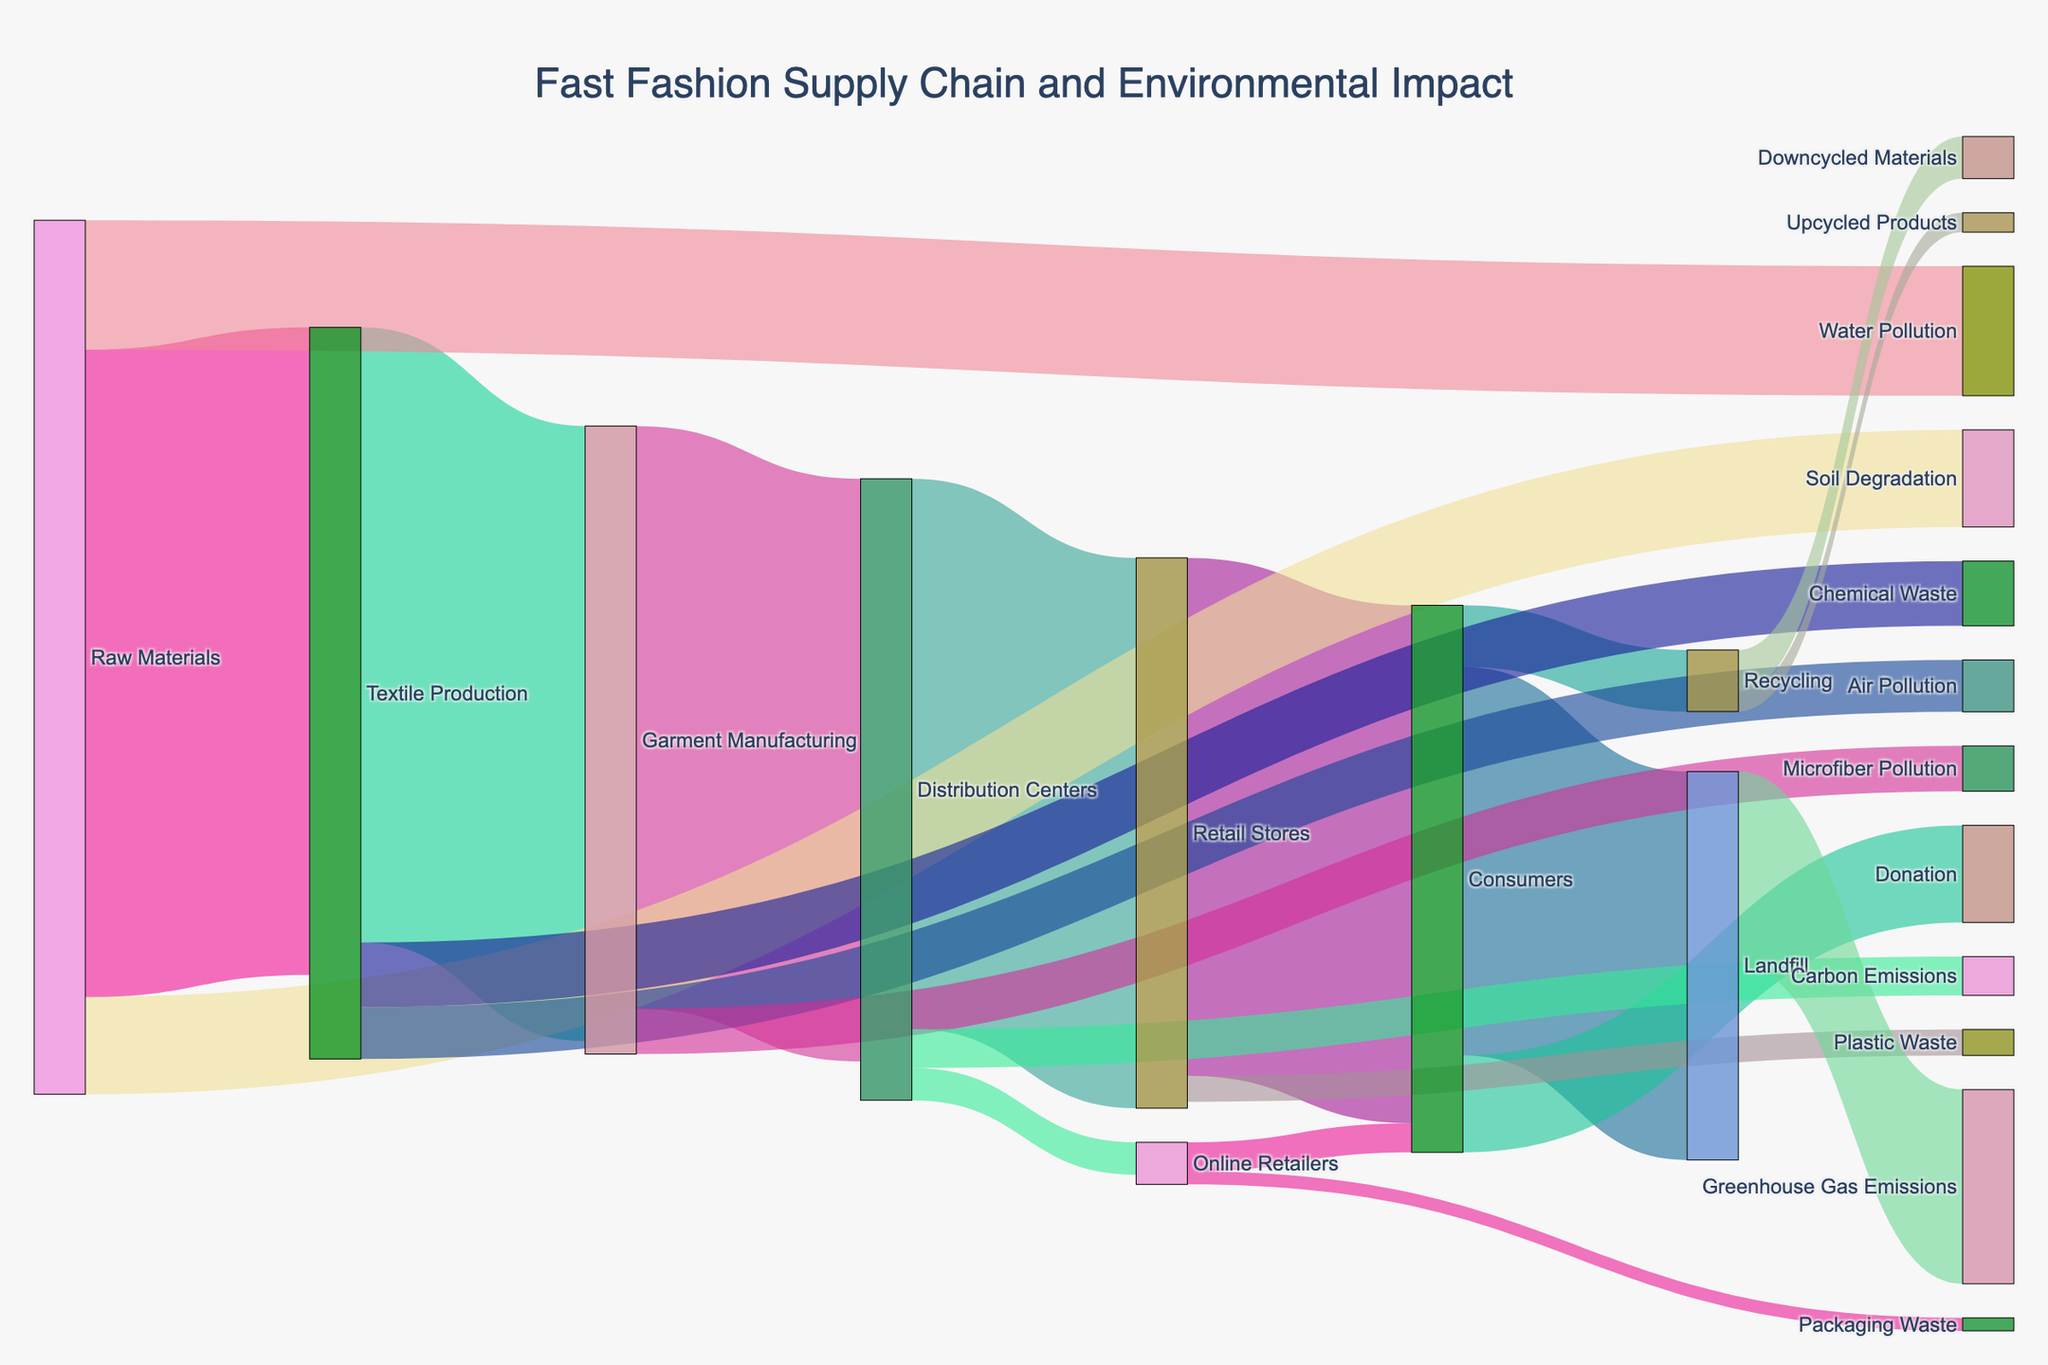What is the title of the Sankey diagram? The title is usually displayed at the top center of the diagram. Here, it reads "Fast Fashion Supply Chain and Environmental Impact".
Answer: Fast Fashion Supply Chain and Environmental Impact What process has the highest value flowing to Distribution Centers? Observing the flow into Distribution Centers, the highest value comes from Garment Manufacturing, with a value of 900.
Answer: Garment Manufacturing What's the sum of the values flowing out from Consumers? Summing the values flowing out from Consumers (600 to Landfill, 150 to Donation, and 95 to Recycling) results in 845.
Answer: 845 Which target receives the smallest value from Online Retailers? From Online Retailers, Consumers receive 45 and Packaging Waste receives 20. Packaging Waste is the smallest value.
Answer: Packaging Waste Which environmental impact receives the most flow from Consumers? From Consumers, the flows are 600 to Landfill, 150 to Donation, and 95 to Recycling. The largest is Landfill with 600.
Answer: Landfill How does the flow from Raw Materials to Soil Degradation compare with the flow to Water Pollution? The flow from Raw Materials to Soil Degradation is 150 while to Water Pollution is 200. Therefore, the flow to Water Pollution is higher.
Answer: Water Pollution is higher What are the values of the flows contributing to Greenhouse Gas Emissions? The only flow that contributes to Greenhouse Gas Emissions is from Landfill with a value of 300.
Answer: 300 Which has a smaller impact: Plastic Waste or Microfiber Pollution? Looking at the flow values, Plastic Waste from Retail Stores is 40, while Microfiber Pollution from Garment Manufacturing is 70. Therefore, Plastic Waste has a smaller impact.
Answer: Plastic Waste Where do Recycled products go after Recycling? After Recycling, the flows go to Upcycled Products (30) and Downcycled Materials (65).
Answer: Upcycled Products and Downcycled Materials 